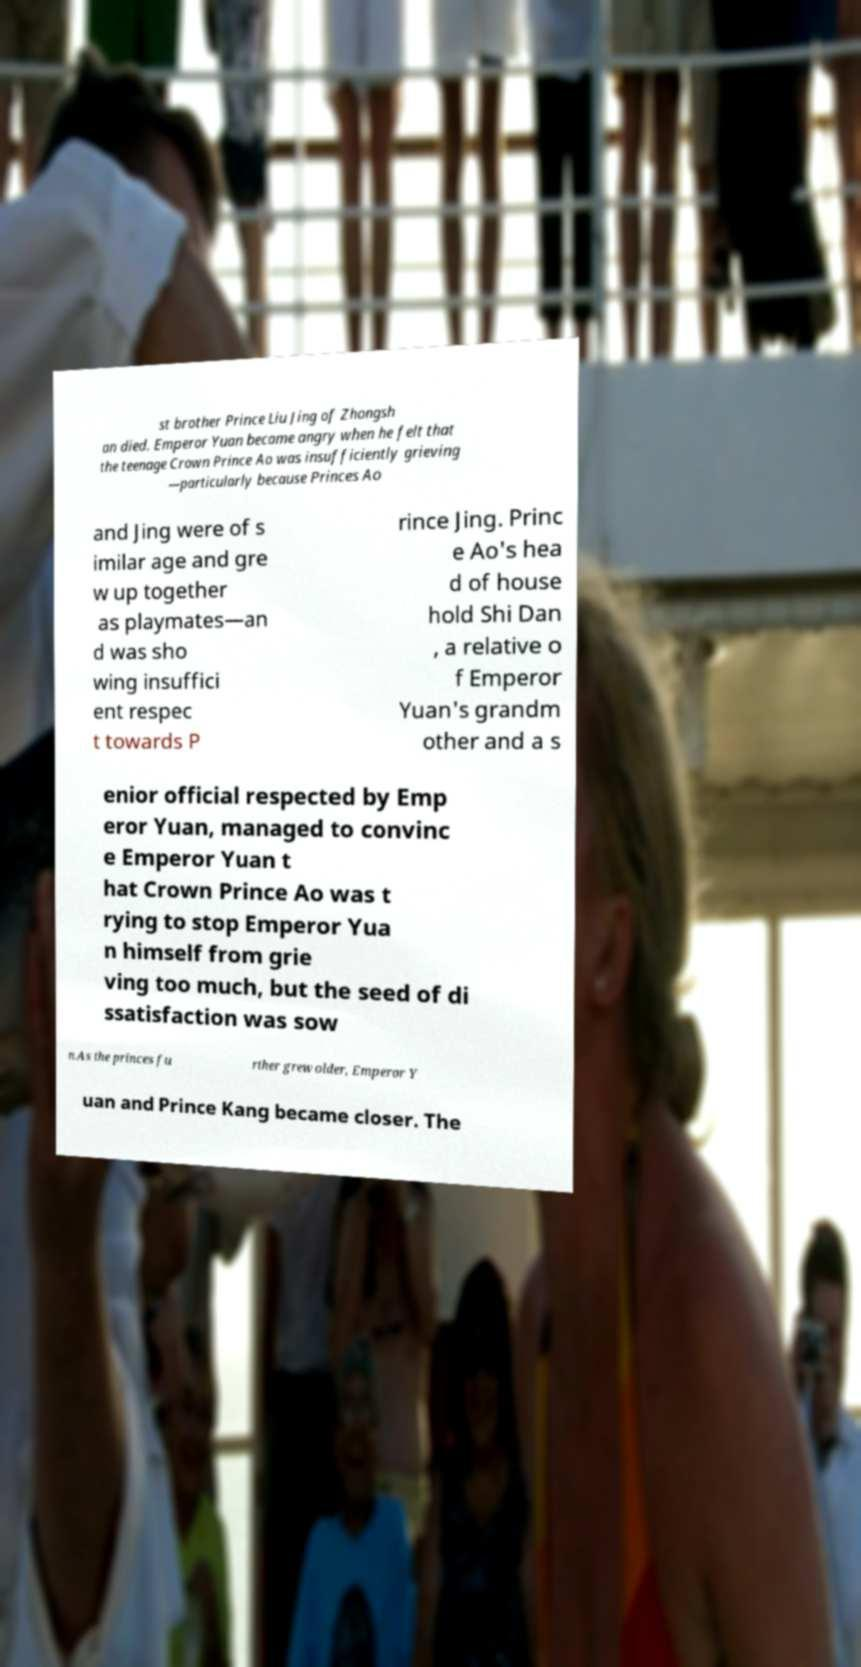Please read and relay the text visible in this image. What does it say? st brother Prince Liu Jing of Zhongsh an died. Emperor Yuan became angry when he felt that the teenage Crown Prince Ao was insufficiently grieving —particularly because Princes Ao and Jing were of s imilar age and gre w up together as playmates—an d was sho wing insuffici ent respec t towards P rince Jing. Princ e Ao's hea d of house hold Shi Dan , a relative o f Emperor Yuan's grandm other and a s enior official respected by Emp eror Yuan, managed to convinc e Emperor Yuan t hat Crown Prince Ao was t rying to stop Emperor Yua n himself from grie ving too much, but the seed of di ssatisfaction was sow n.As the princes fu rther grew older, Emperor Y uan and Prince Kang became closer. The 